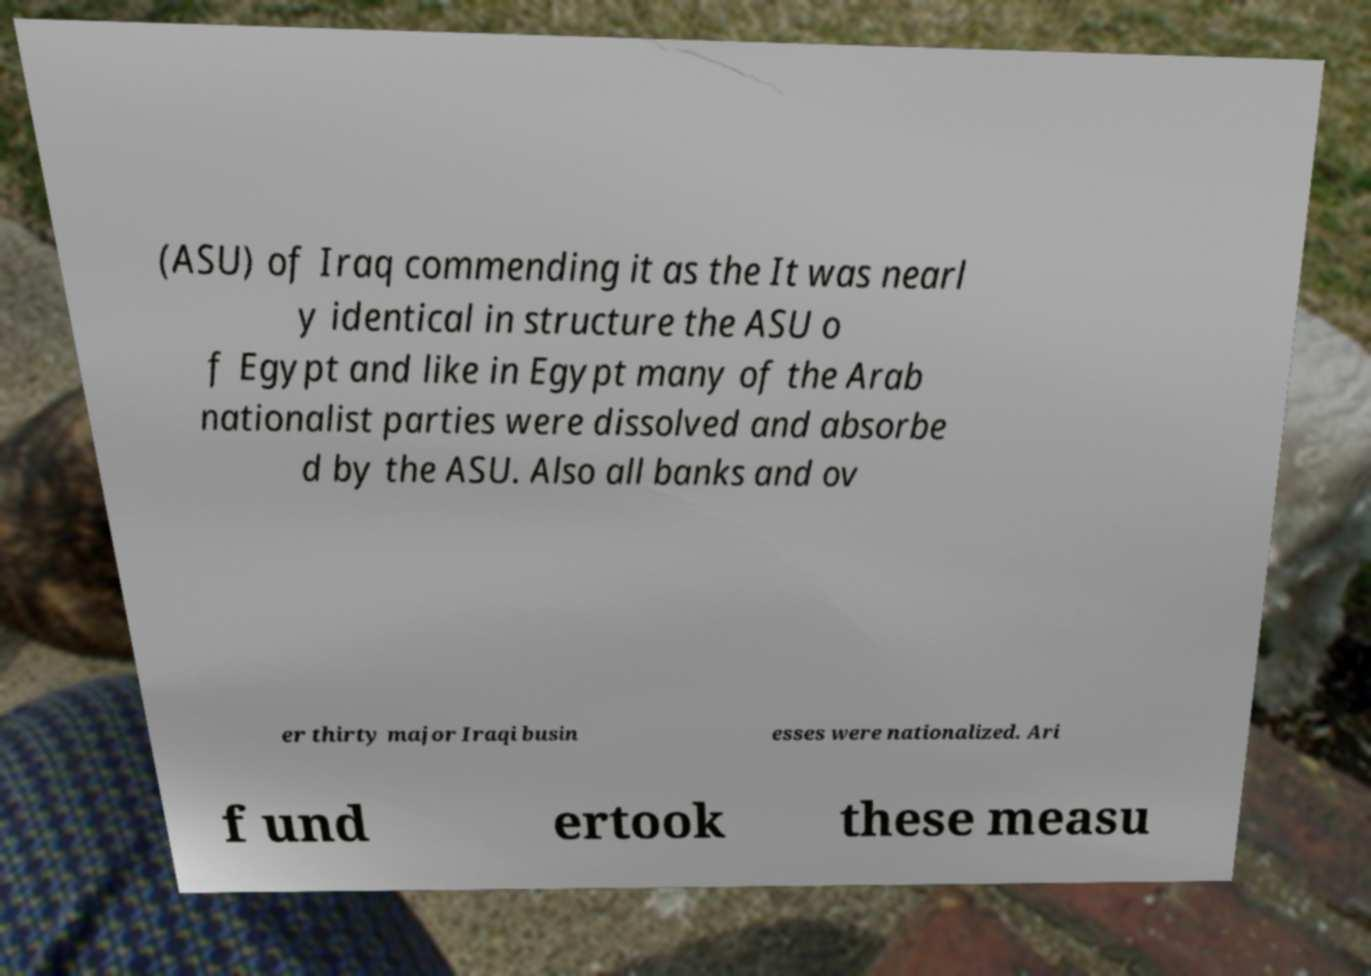For documentation purposes, I need the text within this image transcribed. Could you provide that? (ASU) of Iraq commending it as the It was nearl y identical in structure the ASU o f Egypt and like in Egypt many of the Arab nationalist parties were dissolved and absorbe d by the ASU. Also all banks and ov er thirty major Iraqi busin esses were nationalized. Ari f und ertook these measu 